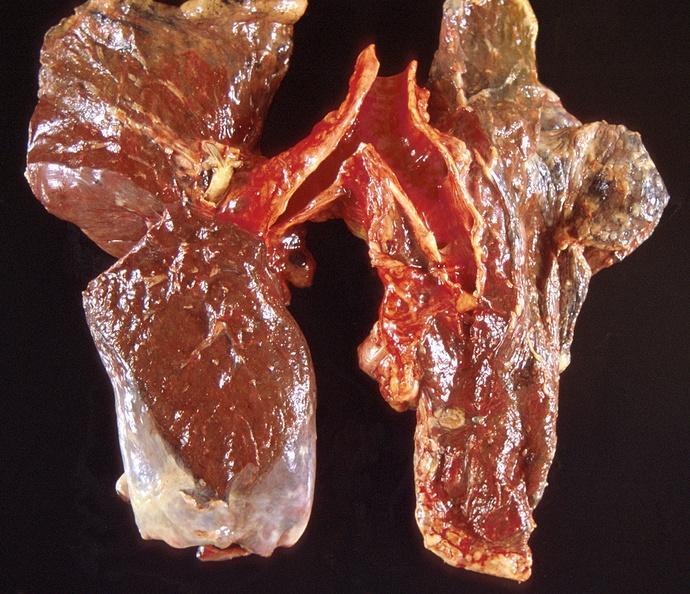what is present?
Answer the question using a single word or phrase. Respiratory 